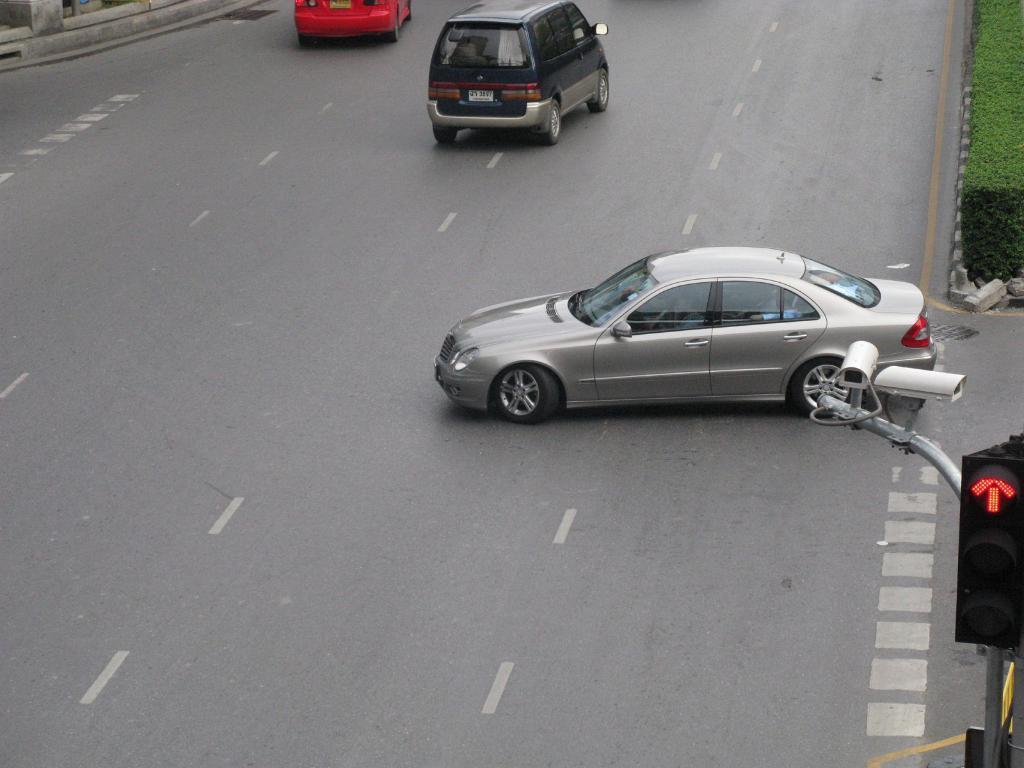Please provide a concise description of this image. In this image we can see motor vehicles on the road, traffic lights, traffic pole, cc camera and grass. 